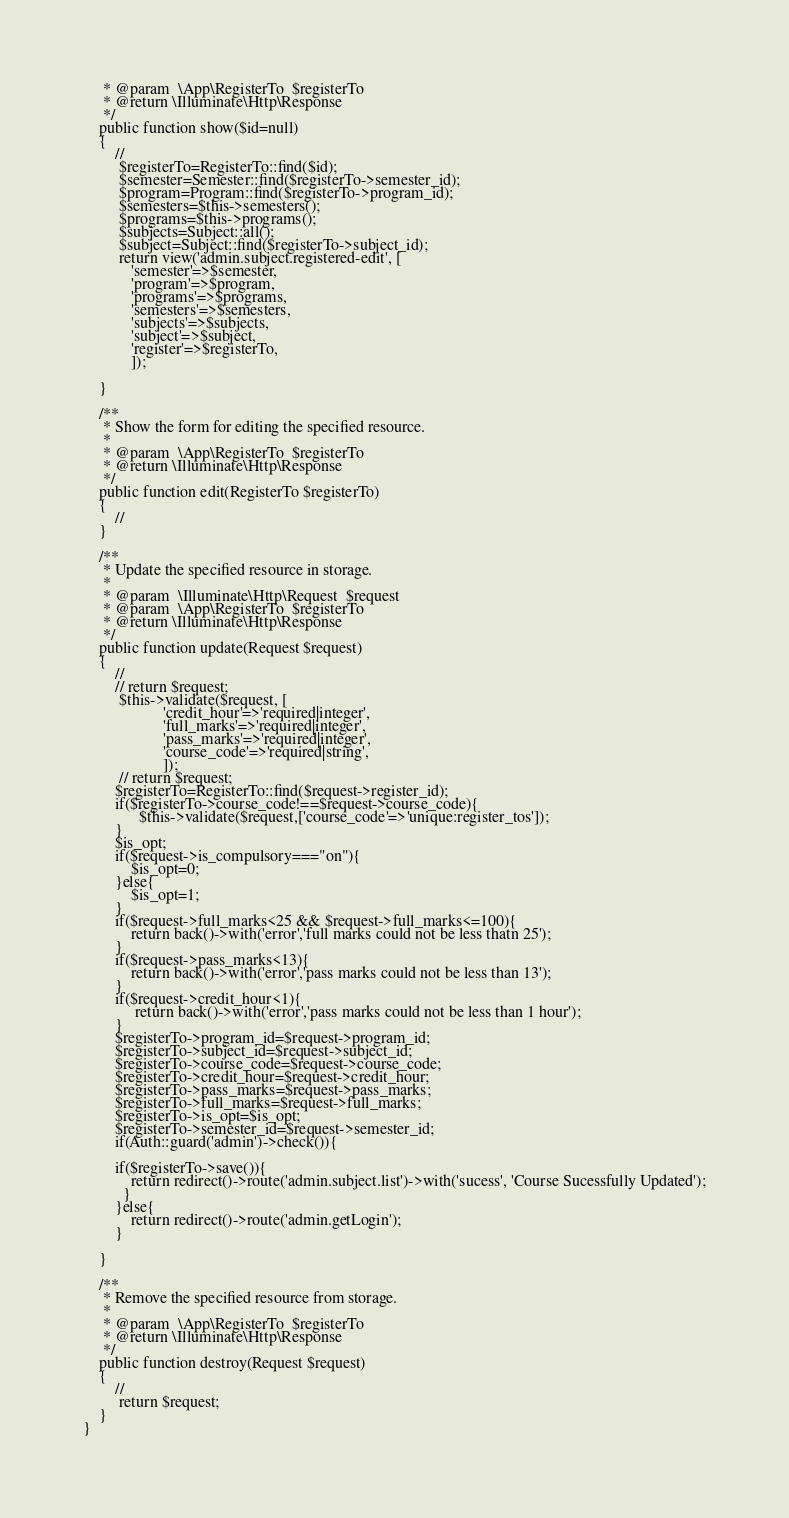Convert code to text. <code><loc_0><loc_0><loc_500><loc_500><_PHP_>     * @param  \App\RegisterTo  $registerTo
     * @return \Illuminate\Http\Response
     */
    public function show($id=null)
    {
        //
         $registerTo=RegisterTo::find($id);
         $semester=Semester::find($registerTo->semester_id);
         $program=Program::find($registerTo->program_id);
         $semesters=$this->semesters();
         $programs=$this->programs();
         $subjects=Subject::all();
         $subject=Subject::find($registerTo->subject_id);
         return view('admin.subject.registered-edit', [
            'semester'=>$semester,
            'program'=>$program,
            'programs'=>$programs,
            'semesters'=>$semesters,
            'subjects'=>$subjects,
            'subject'=>$subject,
            'register'=>$registerTo,
            ]);

    }

    /**
     * Show the form for editing the specified resource.
     *
     * @param  \App\RegisterTo  $registerTo
     * @return \Illuminate\Http\Response
     */
    public function edit(RegisterTo $registerTo)
    {
        //
    }

    /**
     * Update the specified resource in storage.
     *
     * @param  \Illuminate\Http\Request  $request
     * @param  \App\RegisterTo  $registerTo
     * @return \Illuminate\Http\Response
     */
    public function update(Request $request)
    {
        //
        // return $request;
         $this->validate($request, [
                    'credit_hour'=>'required|integer',
                    'full_marks'=>'required|integer',
                    'pass_marks'=>'required|integer',
                    'course_code'=>'required|string',
                    ]);
         // return $request;
        $registerTo=RegisterTo::find($request->register_id);
        if($registerTo->course_code!==$request->course_code){
              $this->validate($request,['course_code'=>'unique:register_tos']);
        }
        $is_opt;
        if($request->is_compulsory==="on"){
            $is_opt=0;
        }else{
            $is_opt=1;
        }
        if($request->full_marks<25 && $request->full_marks<=100){
            return back()->with('error','full marks could not be less thatn 25');
        }
        if($request->pass_marks<13){
            return back()->with('error','pass marks could not be less than 13');
        }
        if($request->credit_hour<1){
             return back()->with('error','pass marks could not be less than 1 hour');
        }
        $registerTo->program_id=$request->program_id;
        $registerTo->subject_id=$request->subject_id;
        $registerTo->course_code=$request->course_code;
        $registerTo->credit_hour=$request->credit_hour;
        $registerTo->pass_marks=$request->pass_marks;
        $registerTo->full_marks=$request->full_marks;
        $registerTo->is_opt=$is_opt;
        $registerTo->semester_id=$request->semester_id;
        if(Auth::guard('admin')->check()){

        if($registerTo->save()){
            return redirect()->route('admin.subject.list')->with('sucess', 'Course Sucessfully Updated');
          }
        }else{
            return redirect()->route('admin.getLogin');
        }

    }

    /**
     * Remove the specified resource from storage.
     *
     * @param  \App\RegisterTo  $registerTo
     * @return \Illuminate\Http\Response
     */
    public function destroy(Request $request)
    {
        //
         return $request;
    }
}
</code> 